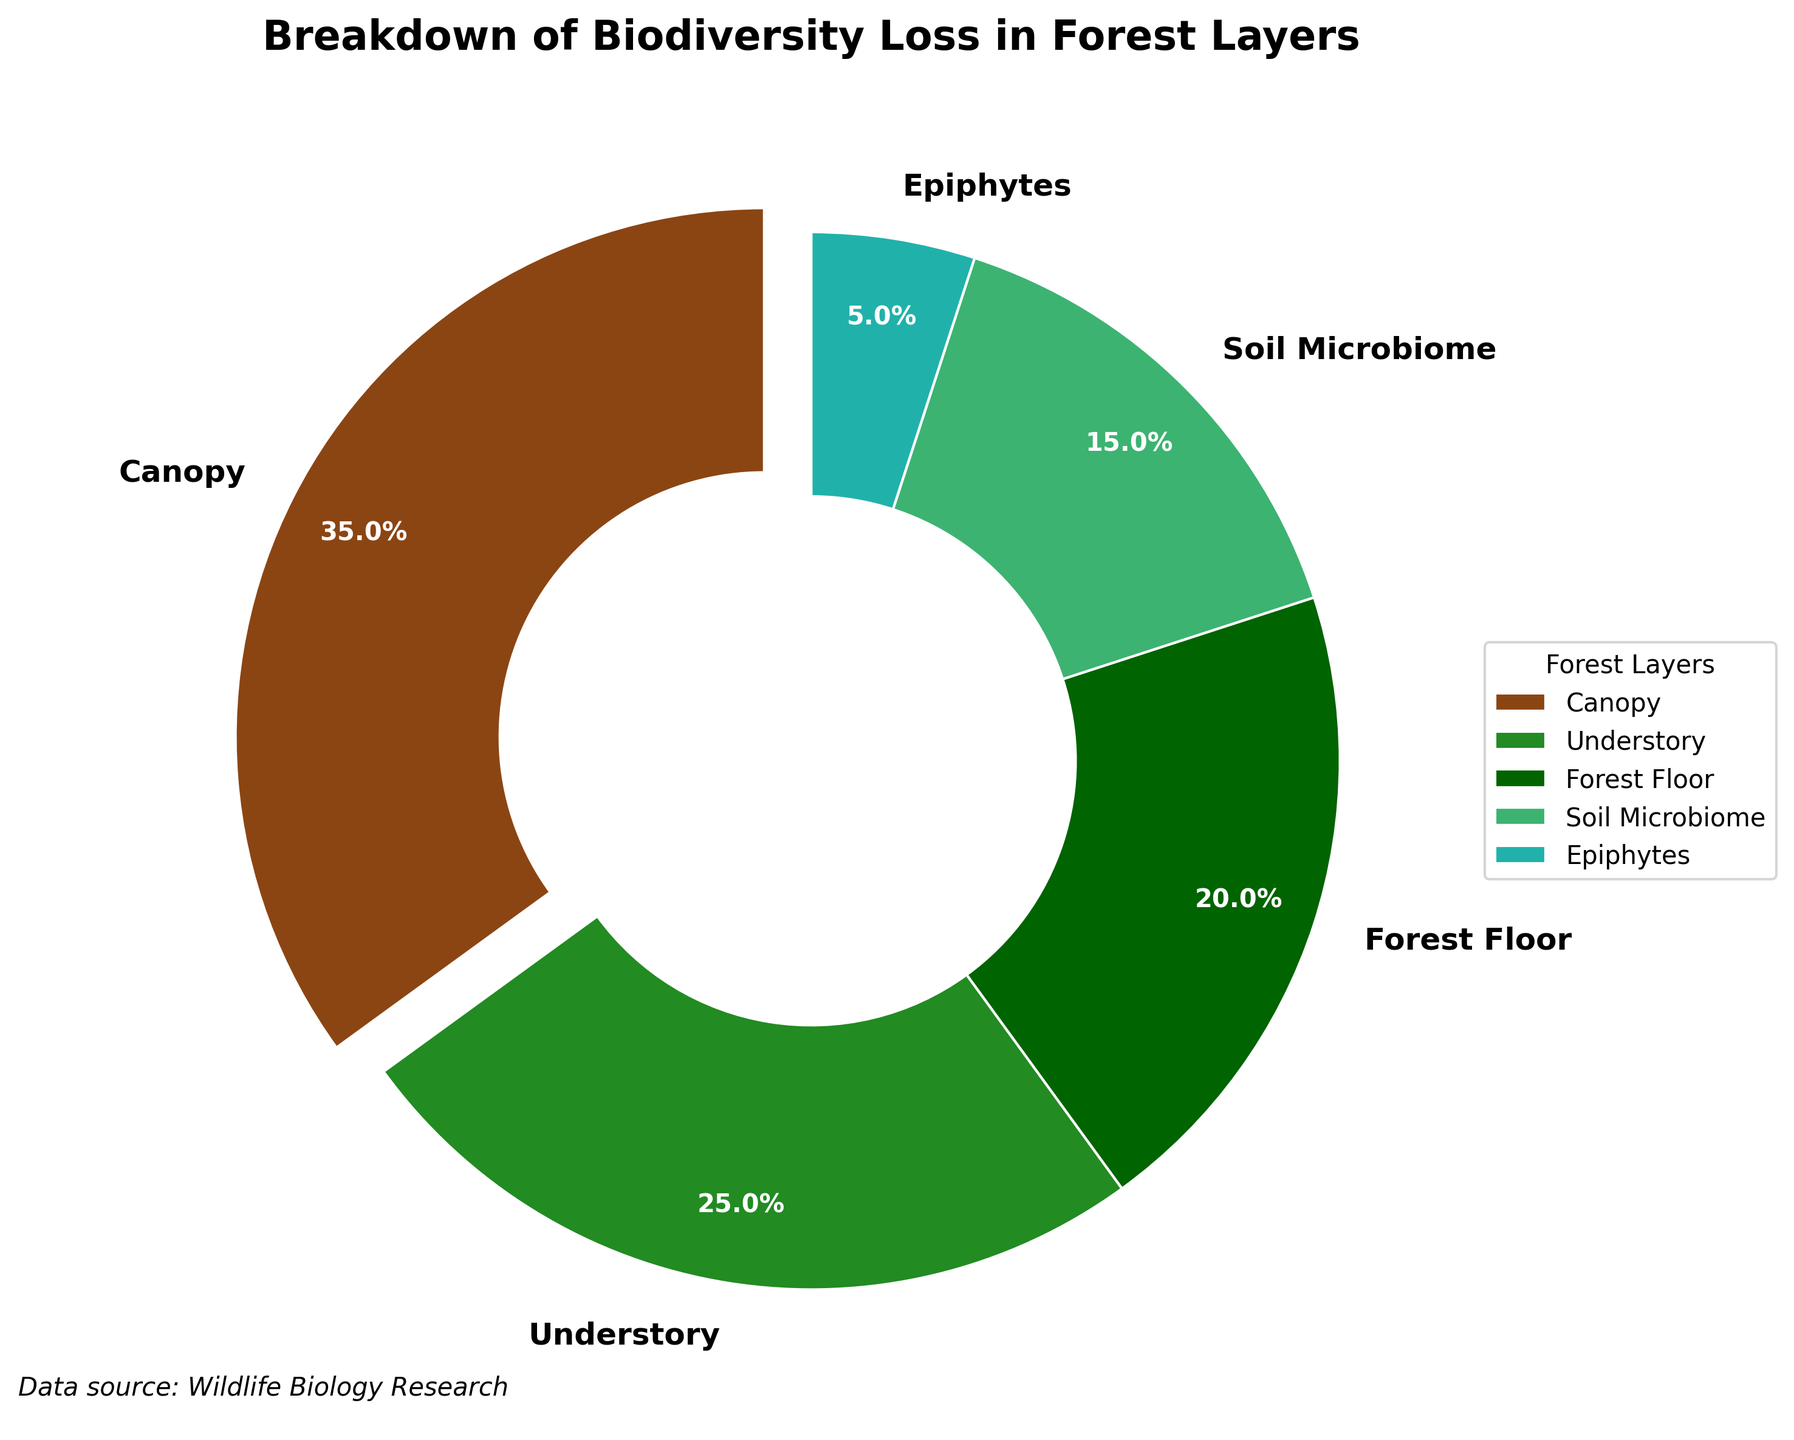What percentage of biodiversity loss is attributed to the canopy layer? The pie chart shows the layers labeled and their associated percentage values. The canopy layer is listed with a percentage value.
Answer: 35% Which forest layer experiences the least biodiversity loss due to deforestation? By examining the percentage values associated with each layer in the pie chart, the epiphytes layer has the lowest percentage.
Answer: Epiphytes How much more biodiversity loss is attributed to the canopy layer compared to the soil microbiome? The canopy layer has a percentage of 35%, and the soil microbiome has 15%. The difference is calculated as 35% - 15% = 20%.
Answer: 20% What is the combined percentage of biodiversity loss in the understory and forest floor layers? The understory layer has 25% and the forest floor layer has 20%. The combined percentage is calculated as 25% + 20% = 45%.
Answer: 45% What is the difference in biodiversity loss between the forest floor and the soil microbiome? The forest floor has 20% and the soil microbiome has 15%. The difference is calculated as 20% - 15% = 5%.
Answer: 5% Which two layers collectively account for more than half of the biodiversity loss? By adding the percentages of each layer, we see that the canopy (35%) and understory (25%) collectively account for 35% + 25% = 60%, which is more than half.
Answer: Canopy and Understory How does the biodiversity loss in the epiphytes layer compare to the understory layer? The epiphytes layer has 5% while the understory has 25%. The epiphytes layer has a substantially lower loss compared to the understory.
Answer: Epiphytes have less biodiversity loss What percentage of biodiversity loss is not accounted for by the canopy layer? The canopy layer accounts for 35%. The remaining percentage is 100% - 35% = 65%.
Answer: 65% 